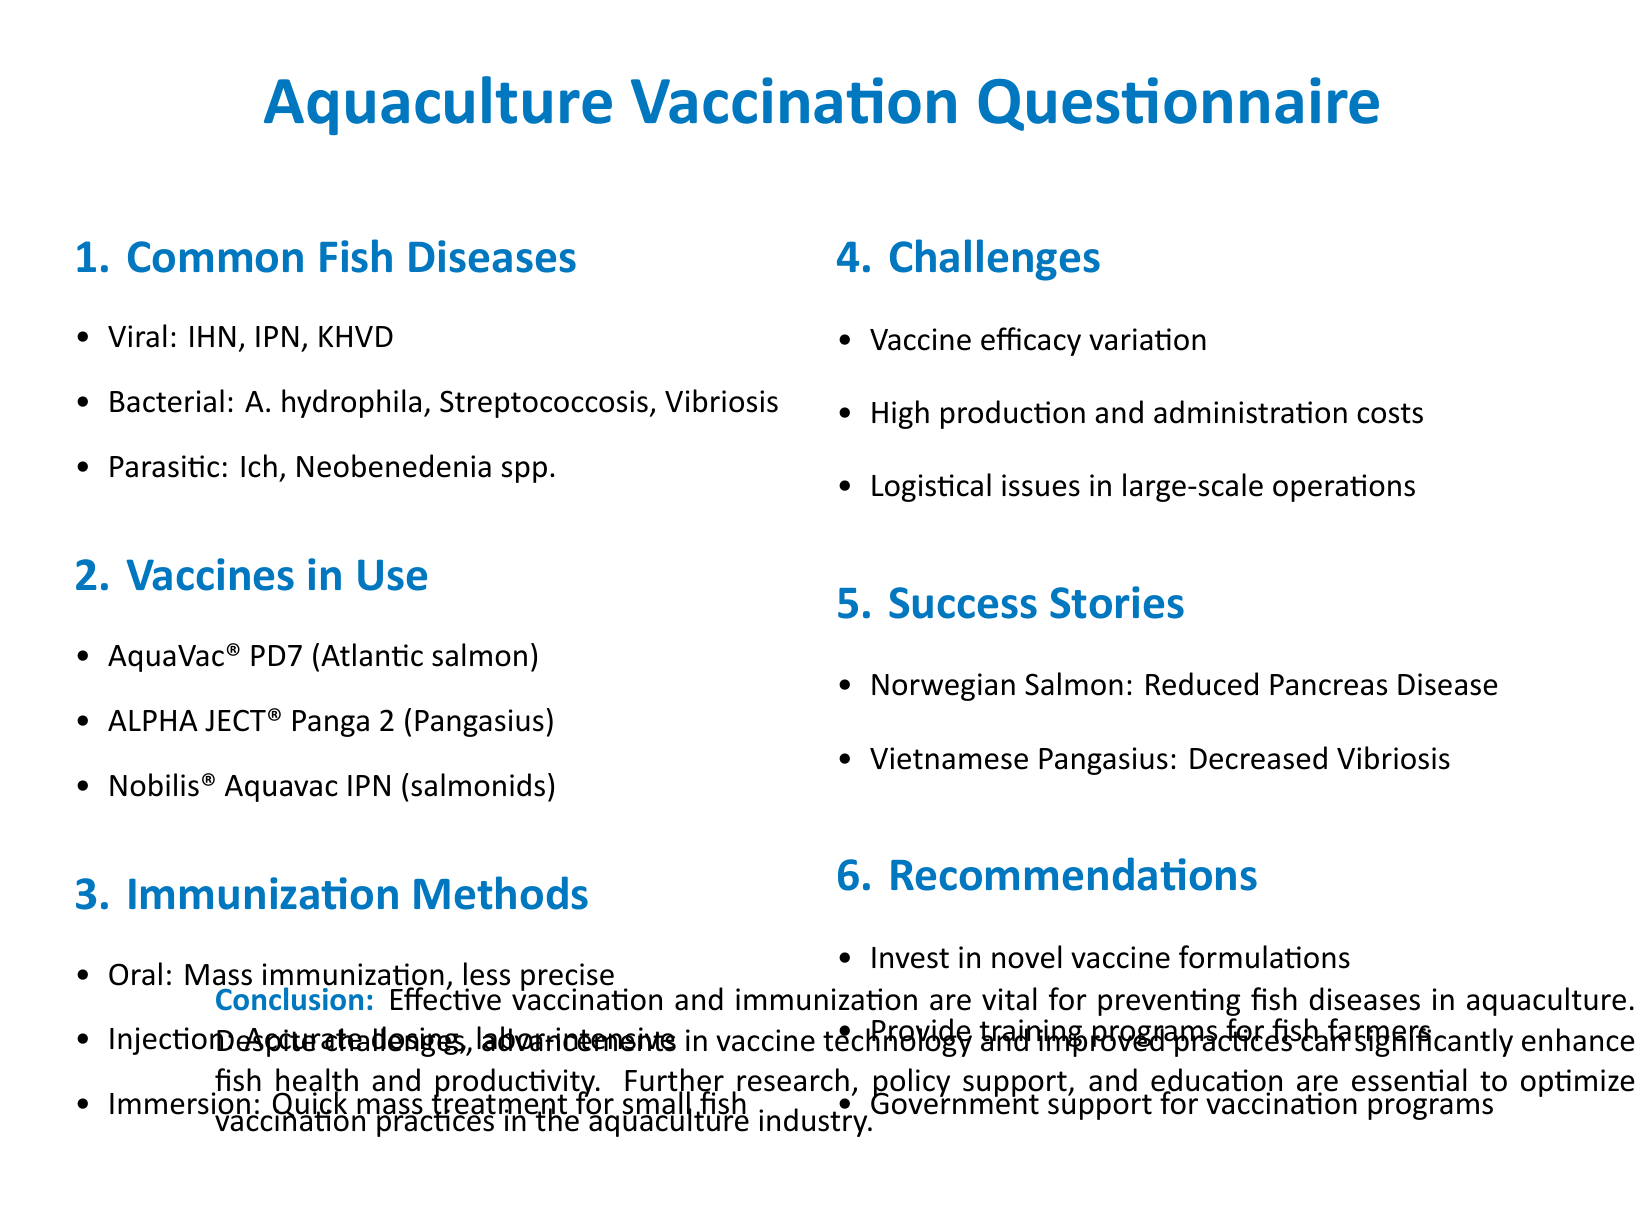What is the title of the questionnaire? The title is presented prominently at the top of the document as "Aquaculture Vaccination Questionnaire."
Answer: Aquaculture Vaccination Questionnaire How many common fish diseases are listed? The document lists three categories of fish diseases: viral, bacterial, and parasitic. Each category includes specific diseases.
Answer: 3 Name one vaccine used for Atlantic salmon. The document specifically mentions AquaVac® PD7 as the vaccine used for Atlantic salmon.
Answer: AquaVac® PD7 What is one challenge faced in vaccination efforts? The document highlights several challenges, one of which is "Vaccine efficacy variation."
Answer: Vaccine efficacy variation What is a recommended approach for fish farmers mentioned in the document? The recommendations section suggests providing training programs for fish farmers to improve practices.
Answer: Training programs for fish farmers Which fish species had a reported success story regarding decreased disease? The document states that Vietnamese Pangasius had a success story related to decreased Vibriosis.
Answer: Vietnamese Pangasius What is the immunization method that is described as labor-intensive? Among the methods described, injection is characterized as accurate dosing but labor-intensive.
Answer: Injection How does the document conclude on the issue of vaccination? The conclusion emphasizes that effective vaccination and immunization are vital for preventing fish diseases in aquaculture.
Answer: Effective vaccination and immunization are vital 